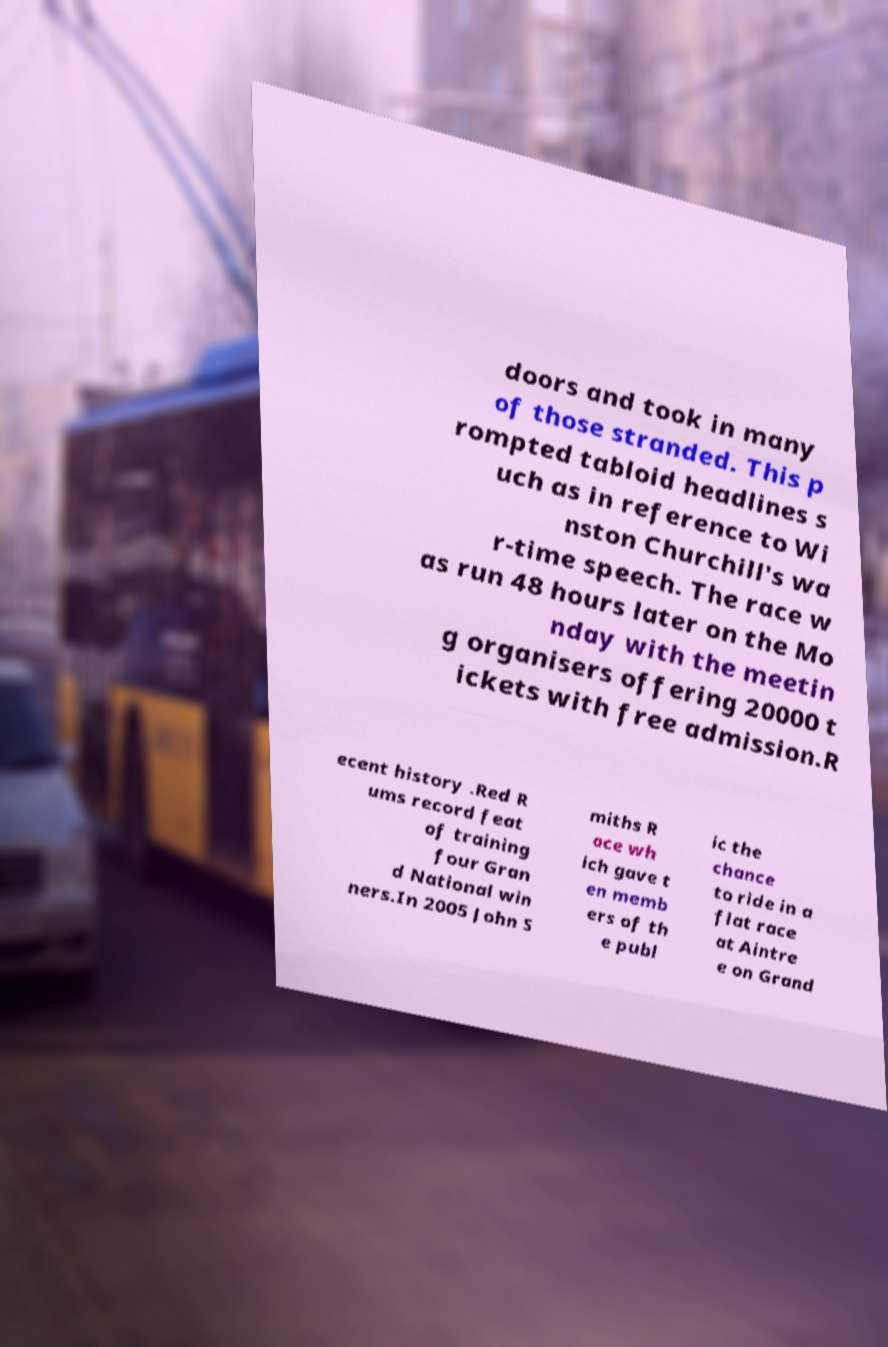There's text embedded in this image that I need extracted. Can you transcribe it verbatim? doors and took in many of those stranded. This p rompted tabloid headlines s uch as in reference to Wi nston Churchill's wa r-time speech. The race w as run 48 hours later on the Mo nday with the meetin g organisers offering 20000 t ickets with free admission.R ecent history .Red R ums record feat of training four Gran d National win ners.In 2005 John S miths R ace wh ich gave t en memb ers of th e publ ic the chance to ride in a flat race at Aintre e on Grand 